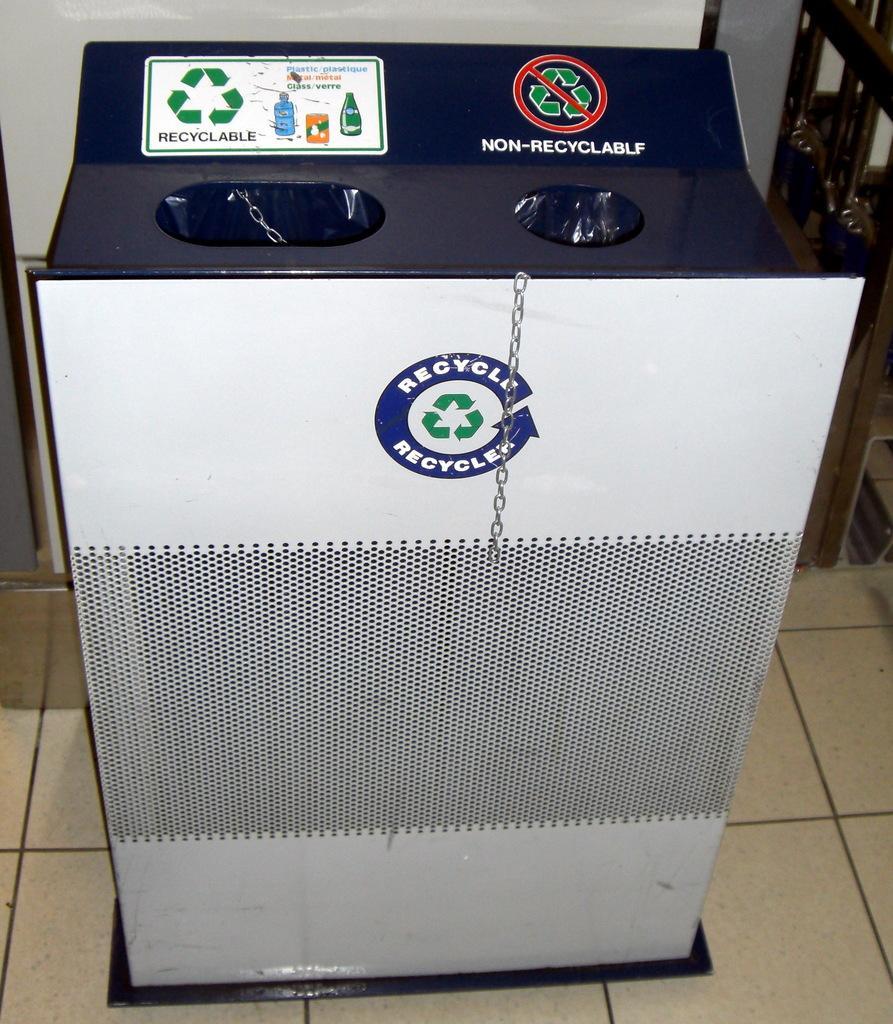How would you summarize this image in a sentence or two? In this image I can see a machine in white and blue color. Background the wall is in white color. 